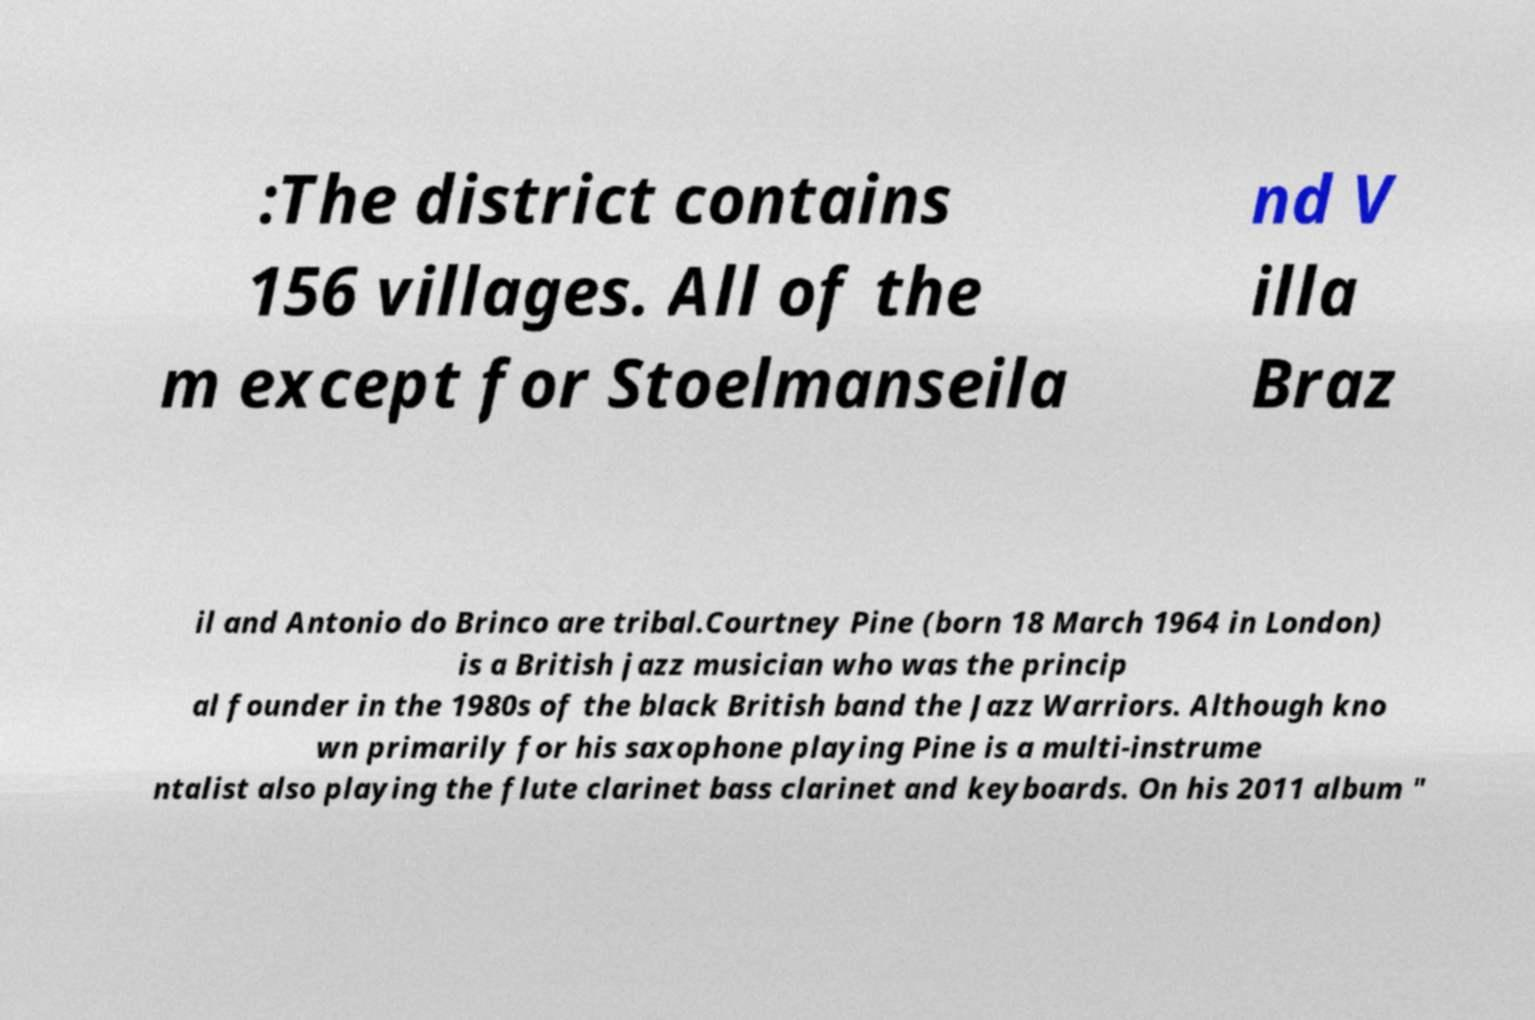Please identify and transcribe the text found in this image. :The district contains 156 villages. All of the m except for Stoelmanseila nd V illa Braz il and Antonio do Brinco are tribal.Courtney Pine (born 18 March 1964 in London) is a British jazz musician who was the princip al founder in the 1980s of the black British band the Jazz Warriors. Although kno wn primarily for his saxophone playing Pine is a multi-instrume ntalist also playing the flute clarinet bass clarinet and keyboards. On his 2011 album " 